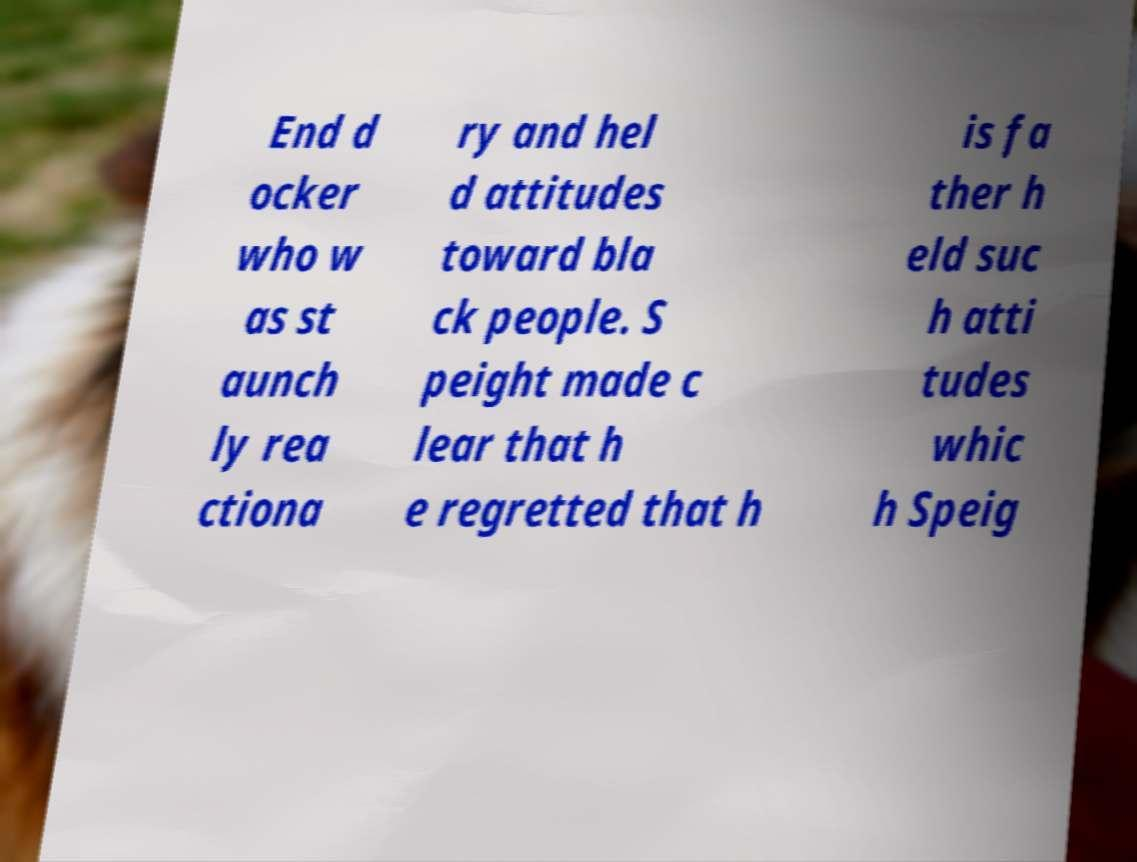I need the written content from this picture converted into text. Can you do that? End d ocker who w as st aunch ly rea ctiona ry and hel d attitudes toward bla ck people. S peight made c lear that h e regretted that h is fa ther h eld suc h atti tudes whic h Speig 